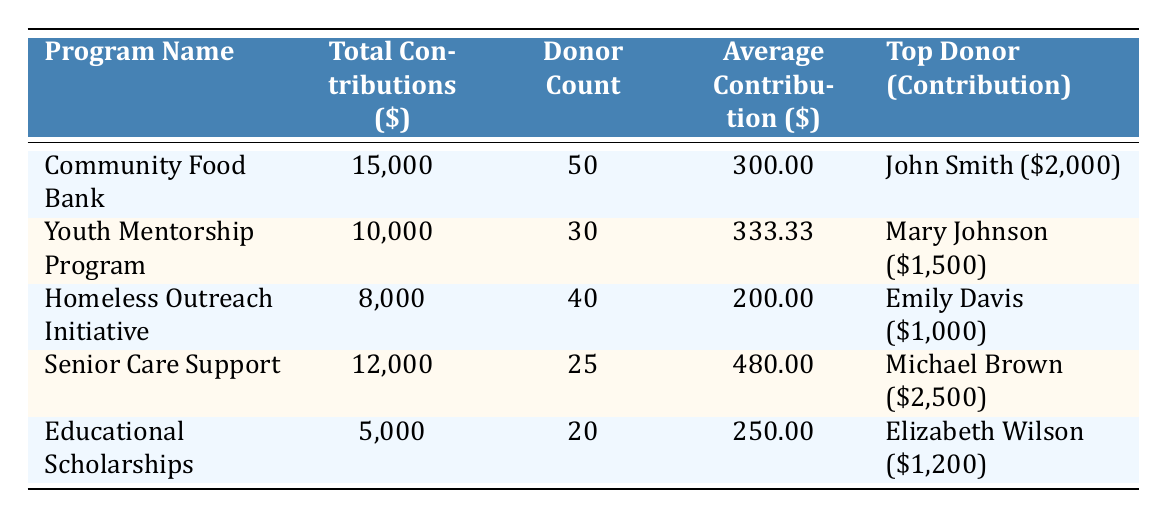What is the total contribution for the Community Food Bank program? The table clearly states the total contributions for the Community Food Bank program as $15,000.
Answer: 15000 Who is the top donor for the Senior Care Support program? According to the table, the top donor for the Senior Care Support program is Michael Brown.
Answer: Michael Brown Which outreach program has the highest average contribution per donor? To find this, compare the average contributions: Community Food Bank ($300), Youth Mentorship Program ($333.33), Homeless Outreach Initiative ($200), Senior Care Support ($480), and Educational Scholarships ($250). The highest average is for the Senior Care Support program at $480.
Answer: Senior Care Support How many total donors contributed across all programs? The total donors from each program are: Community Food Bank (50), Youth Mentorship Program (30), Homeless Outreach Initiative (40), Senior Care Support (25), and Educational Scholarships (20). Adding these gives 50 + 30 + 40 + 25 + 20 = 165 total donors.
Answer: 165 Is it true that the Homeless Outreach Initiative had more total contributions than the Educational Scholarships? From the table, the total contributions for the Homeless Outreach Initiative is $8,000, while it is $5,000 for Educational Scholarships. Therefore, it is true that Homeless Outreach Initiative had more contributions.
Answer: Yes What is the average contribution for the Youth Mentorship Program? The table presents the average contribution for the Youth Mentorship Program as $333.33, which can be directly found in the relevant row.
Answer: 333.33 Which program had the lowest total contributions? Looking at the total contributions listed, Educational Scholarships received $5,000, which is the lowest compared to the others (Community Food Bank, Youth Mentorship Program, Homeless Outreach Initiative, Senior Care Support).
Answer: Educational Scholarships How much more did the top donor of the Senior Care Support program contribute than the top donor of the Community Food Bank? The top donor for the Senior Care Support program contributed $2,500, while the top donor of the Community Food Bank contributed $2,000. The difference is $2,500 - $2,000 = $500.
Answer: 500 